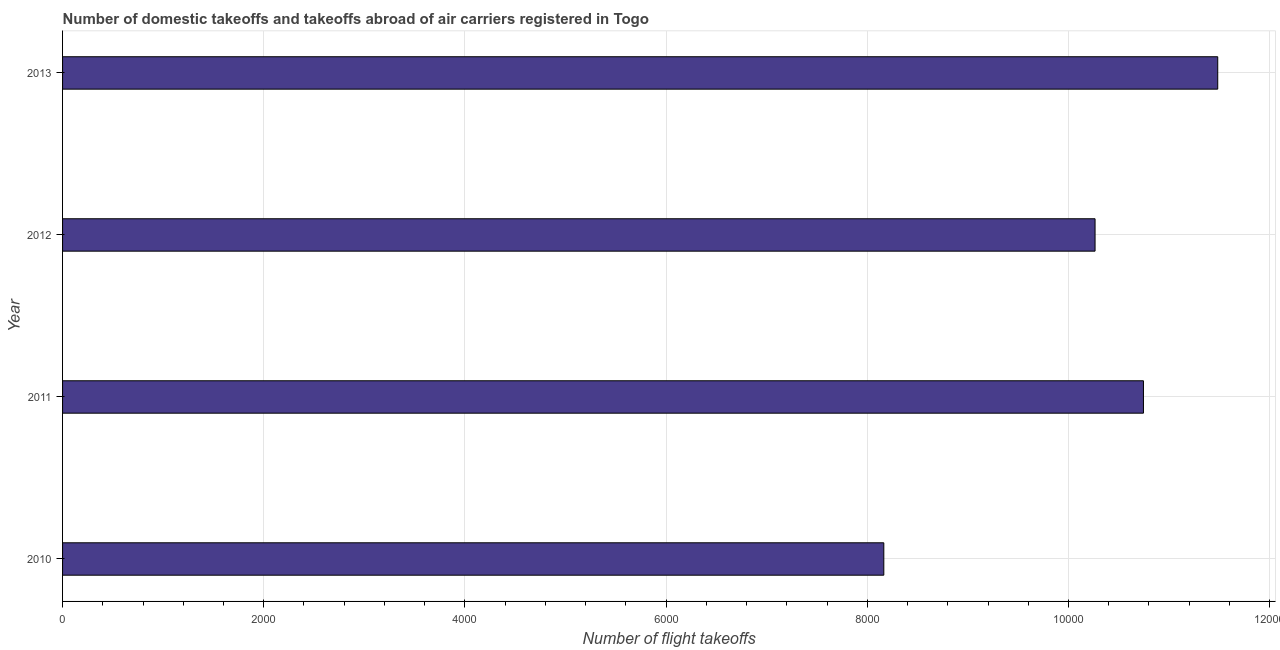What is the title of the graph?
Your answer should be very brief. Number of domestic takeoffs and takeoffs abroad of air carriers registered in Togo. What is the label or title of the X-axis?
Your response must be concise. Number of flight takeoffs. What is the number of flight takeoffs in 2011?
Provide a succinct answer. 1.07e+04. Across all years, what is the maximum number of flight takeoffs?
Offer a very short reply. 1.15e+04. Across all years, what is the minimum number of flight takeoffs?
Keep it short and to the point. 8164. In which year was the number of flight takeoffs maximum?
Provide a succinct answer. 2013. In which year was the number of flight takeoffs minimum?
Provide a short and direct response. 2010. What is the sum of the number of flight takeoffs?
Ensure brevity in your answer.  4.07e+04. What is the difference between the number of flight takeoffs in 2010 and 2012?
Your response must be concise. -2100. What is the average number of flight takeoffs per year?
Provide a short and direct response. 1.02e+04. What is the median number of flight takeoffs?
Your answer should be compact. 1.05e+04. In how many years, is the number of flight takeoffs greater than 10800 ?
Your answer should be very brief. 1. What is the ratio of the number of flight takeoffs in 2012 to that in 2013?
Your response must be concise. 0.89. What is the difference between the highest and the second highest number of flight takeoffs?
Keep it short and to the point. 738.48. What is the difference between the highest and the lowest number of flight takeoffs?
Offer a terse response. 3319.48. How many bars are there?
Make the answer very short. 4. How many years are there in the graph?
Keep it short and to the point. 4. What is the difference between two consecutive major ticks on the X-axis?
Make the answer very short. 2000. What is the Number of flight takeoffs in 2010?
Keep it short and to the point. 8164. What is the Number of flight takeoffs in 2011?
Ensure brevity in your answer.  1.07e+04. What is the Number of flight takeoffs of 2012?
Make the answer very short. 1.03e+04. What is the Number of flight takeoffs of 2013?
Provide a short and direct response. 1.15e+04. What is the difference between the Number of flight takeoffs in 2010 and 2011?
Ensure brevity in your answer.  -2581. What is the difference between the Number of flight takeoffs in 2010 and 2012?
Offer a terse response. -2100. What is the difference between the Number of flight takeoffs in 2010 and 2013?
Your response must be concise. -3319.48. What is the difference between the Number of flight takeoffs in 2011 and 2012?
Provide a succinct answer. 481. What is the difference between the Number of flight takeoffs in 2011 and 2013?
Your answer should be very brief. -738.48. What is the difference between the Number of flight takeoffs in 2012 and 2013?
Provide a succinct answer. -1219.48. What is the ratio of the Number of flight takeoffs in 2010 to that in 2011?
Give a very brief answer. 0.76. What is the ratio of the Number of flight takeoffs in 2010 to that in 2012?
Your response must be concise. 0.8. What is the ratio of the Number of flight takeoffs in 2010 to that in 2013?
Your answer should be compact. 0.71. What is the ratio of the Number of flight takeoffs in 2011 to that in 2012?
Provide a succinct answer. 1.05. What is the ratio of the Number of flight takeoffs in 2011 to that in 2013?
Keep it short and to the point. 0.94. What is the ratio of the Number of flight takeoffs in 2012 to that in 2013?
Provide a succinct answer. 0.89. 